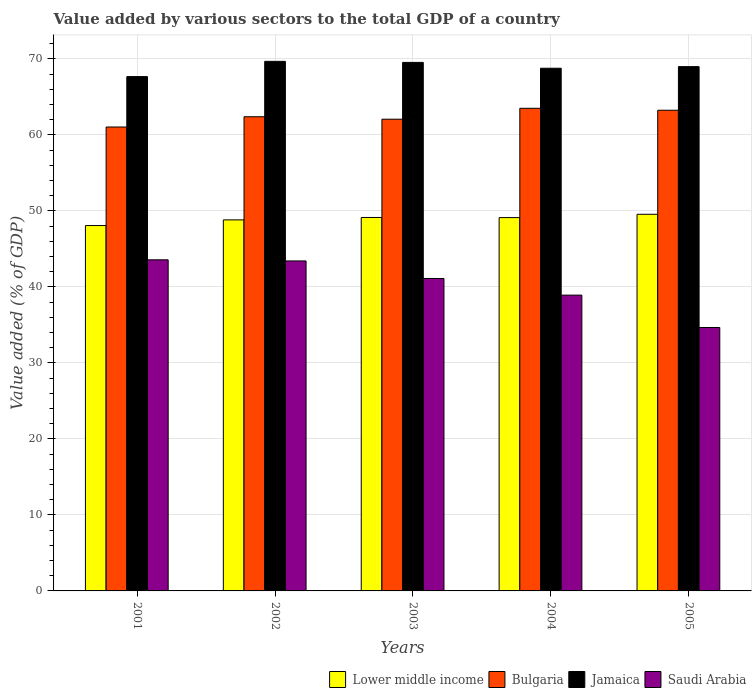How many bars are there on the 2nd tick from the right?
Keep it short and to the point. 4. In how many cases, is the number of bars for a given year not equal to the number of legend labels?
Make the answer very short. 0. What is the value added by various sectors to the total GDP in Bulgaria in 2004?
Make the answer very short. 63.51. Across all years, what is the maximum value added by various sectors to the total GDP in Saudi Arabia?
Give a very brief answer. 43.57. Across all years, what is the minimum value added by various sectors to the total GDP in Jamaica?
Your answer should be very brief. 67.68. In which year was the value added by various sectors to the total GDP in Bulgaria minimum?
Provide a succinct answer. 2001. What is the total value added by various sectors to the total GDP in Jamaica in the graph?
Offer a terse response. 344.68. What is the difference between the value added by various sectors to the total GDP in Bulgaria in 2001 and that in 2005?
Provide a succinct answer. -2.21. What is the difference between the value added by various sectors to the total GDP in Lower middle income in 2002 and the value added by various sectors to the total GDP in Saudi Arabia in 2004?
Your answer should be very brief. 9.9. What is the average value added by various sectors to the total GDP in Saudi Arabia per year?
Give a very brief answer. 40.34. In the year 2003, what is the difference between the value added by various sectors to the total GDP in Jamaica and value added by various sectors to the total GDP in Bulgaria?
Your response must be concise. 7.48. In how many years, is the value added by various sectors to the total GDP in Bulgaria greater than 62 %?
Provide a short and direct response. 4. What is the ratio of the value added by various sectors to the total GDP in Bulgaria in 2004 to that in 2005?
Offer a very short reply. 1. Is the value added by various sectors to the total GDP in Jamaica in 2003 less than that in 2004?
Keep it short and to the point. No. Is the difference between the value added by various sectors to the total GDP in Jamaica in 2001 and 2003 greater than the difference between the value added by various sectors to the total GDP in Bulgaria in 2001 and 2003?
Make the answer very short. No. What is the difference between the highest and the second highest value added by various sectors to the total GDP in Jamaica?
Offer a terse response. 0.14. What is the difference between the highest and the lowest value added by various sectors to the total GDP in Lower middle income?
Make the answer very short. 1.48. What does the 1st bar from the left in 2002 represents?
Ensure brevity in your answer.  Lower middle income. How many bars are there?
Offer a terse response. 20. What is the title of the graph?
Give a very brief answer. Value added by various sectors to the total GDP of a country. What is the label or title of the Y-axis?
Keep it short and to the point. Value added (% of GDP). What is the Value added (% of GDP) of Lower middle income in 2001?
Your answer should be very brief. 48.08. What is the Value added (% of GDP) of Bulgaria in 2001?
Give a very brief answer. 61.05. What is the Value added (% of GDP) in Jamaica in 2001?
Make the answer very short. 67.68. What is the Value added (% of GDP) of Saudi Arabia in 2001?
Offer a terse response. 43.57. What is the Value added (% of GDP) in Lower middle income in 2002?
Make the answer very short. 48.82. What is the Value added (% of GDP) of Bulgaria in 2002?
Your response must be concise. 62.4. What is the Value added (% of GDP) of Jamaica in 2002?
Your response must be concise. 69.69. What is the Value added (% of GDP) in Saudi Arabia in 2002?
Your answer should be very brief. 43.42. What is the Value added (% of GDP) of Lower middle income in 2003?
Provide a succinct answer. 49.14. What is the Value added (% of GDP) in Bulgaria in 2003?
Keep it short and to the point. 62.07. What is the Value added (% of GDP) in Jamaica in 2003?
Give a very brief answer. 69.55. What is the Value added (% of GDP) of Saudi Arabia in 2003?
Your answer should be compact. 41.11. What is the Value added (% of GDP) in Lower middle income in 2004?
Give a very brief answer. 49.12. What is the Value added (% of GDP) in Bulgaria in 2004?
Offer a very short reply. 63.51. What is the Value added (% of GDP) in Jamaica in 2004?
Provide a succinct answer. 68.78. What is the Value added (% of GDP) in Saudi Arabia in 2004?
Your response must be concise. 38.92. What is the Value added (% of GDP) in Lower middle income in 2005?
Your answer should be very brief. 49.56. What is the Value added (% of GDP) in Bulgaria in 2005?
Your answer should be compact. 63.25. What is the Value added (% of GDP) in Jamaica in 2005?
Your response must be concise. 68.99. What is the Value added (% of GDP) in Saudi Arabia in 2005?
Provide a succinct answer. 34.66. Across all years, what is the maximum Value added (% of GDP) of Lower middle income?
Your response must be concise. 49.56. Across all years, what is the maximum Value added (% of GDP) of Bulgaria?
Keep it short and to the point. 63.51. Across all years, what is the maximum Value added (% of GDP) of Jamaica?
Make the answer very short. 69.69. Across all years, what is the maximum Value added (% of GDP) of Saudi Arabia?
Keep it short and to the point. 43.57. Across all years, what is the minimum Value added (% of GDP) of Lower middle income?
Your answer should be compact. 48.08. Across all years, what is the minimum Value added (% of GDP) in Bulgaria?
Ensure brevity in your answer.  61.05. Across all years, what is the minimum Value added (% of GDP) of Jamaica?
Your answer should be very brief. 67.68. Across all years, what is the minimum Value added (% of GDP) of Saudi Arabia?
Your answer should be compact. 34.66. What is the total Value added (% of GDP) of Lower middle income in the graph?
Offer a terse response. 244.73. What is the total Value added (% of GDP) in Bulgaria in the graph?
Provide a short and direct response. 312.28. What is the total Value added (% of GDP) of Jamaica in the graph?
Offer a very short reply. 344.68. What is the total Value added (% of GDP) of Saudi Arabia in the graph?
Your response must be concise. 201.69. What is the difference between the Value added (% of GDP) in Lower middle income in 2001 and that in 2002?
Make the answer very short. -0.75. What is the difference between the Value added (% of GDP) of Bulgaria in 2001 and that in 2002?
Your response must be concise. -1.35. What is the difference between the Value added (% of GDP) of Jamaica in 2001 and that in 2002?
Your answer should be compact. -2.01. What is the difference between the Value added (% of GDP) of Saudi Arabia in 2001 and that in 2002?
Keep it short and to the point. 0.15. What is the difference between the Value added (% of GDP) of Lower middle income in 2001 and that in 2003?
Provide a short and direct response. -1.06. What is the difference between the Value added (% of GDP) of Bulgaria in 2001 and that in 2003?
Your answer should be compact. -1.03. What is the difference between the Value added (% of GDP) of Jamaica in 2001 and that in 2003?
Your answer should be very brief. -1.87. What is the difference between the Value added (% of GDP) in Saudi Arabia in 2001 and that in 2003?
Keep it short and to the point. 2.46. What is the difference between the Value added (% of GDP) of Lower middle income in 2001 and that in 2004?
Your answer should be compact. -1.05. What is the difference between the Value added (% of GDP) of Bulgaria in 2001 and that in 2004?
Provide a succinct answer. -2.46. What is the difference between the Value added (% of GDP) of Jamaica in 2001 and that in 2004?
Give a very brief answer. -1.1. What is the difference between the Value added (% of GDP) of Saudi Arabia in 2001 and that in 2004?
Provide a succinct answer. 4.65. What is the difference between the Value added (% of GDP) of Lower middle income in 2001 and that in 2005?
Make the answer very short. -1.48. What is the difference between the Value added (% of GDP) of Bulgaria in 2001 and that in 2005?
Provide a succinct answer. -2.21. What is the difference between the Value added (% of GDP) in Jamaica in 2001 and that in 2005?
Provide a succinct answer. -1.31. What is the difference between the Value added (% of GDP) in Saudi Arabia in 2001 and that in 2005?
Your answer should be compact. 8.91. What is the difference between the Value added (% of GDP) in Lower middle income in 2002 and that in 2003?
Ensure brevity in your answer.  -0.32. What is the difference between the Value added (% of GDP) of Bulgaria in 2002 and that in 2003?
Offer a terse response. 0.32. What is the difference between the Value added (% of GDP) in Jamaica in 2002 and that in 2003?
Provide a short and direct response. 0.14. What is the difference between the Value added (% of GDP) of Saudi Arabia in 2002 and that in 2003?
Provide a succinct answer. 2.31. What is the difference between the Value added (% of GDP) of Lower middle income in 2002 and that in 2004?
Provide a short and direct response. -0.3. What is the difference between the Value added (% of GDP) of Bulgaria in 2002 and that in 2004?
Keep it short and to the point. -1.11. What is the difference between the Value added (% of GDP) of Jamaica in 2002 and that in 2004?
Provide a succinct answer. 0.91. What is the difference between the Value added (% of GDP) in Saudi Arabia in 2002 and that in 2004?
Your answer should be very brief. 4.5. What is the difference between the Value added (% of GDP) in Lower middle income in 2002 and that in 2005?
Your answer should be compact. -0.74. What is the difference between the Value added (% of GDP) in Bulgaria in 2002 and that in 2005?
Provide a short and direct response. -0.86. What is the difference between the Value added (% of GDP) of Jamaica in 2002 and that in 2005?
Ensure brevity in your answer.  0.69. What is the difference between the Value added (% of GDP) in Saudi Arabia in 2002 and that in 2005?
Offer a very short reply. 8.76. What is the difference between the Value added (% of GDP) in Lower middle income in 2003 and that in 2004?
Provide a succinct answer. 0.02. What is the difference between the Value added (% of GDP) of Bulgaria in 2003 and that in 2004?
Keep it short and to the point. -1.44. What is the difference between the Value added (% of GDP) in Jamaica in 2003 and that in 2004?
Offer a very short reply. 0.77. What is the difference between the Value added (% of GDP) of Saudi Arabia in 2003 and that in 2004?
Make the answer very short. 2.19. What is the difference between the Value added (% of GDP) of Lower middle income in 2003 and that in 2005?
Offer a very short reply. -0.42. What is the difference between the Value added (% of GDP) in Bulgaria in 2003 and that in 2005?
Your response must be concise. -1.18. What is the difference between the Value added (% of GDP) in Jamaica in 2003 and that in 2005?
Your response must be concise. 0.56. What is the difference between the Value added (% of GDP) of Saudi Arabia in 2003 and that in 2005?
Offer a terse response. 6.45. What is the difference between the Value added (% of GDP) in Lower middle income in 2004 and that in 2005?
Your response must be concise. -0.44. What is the difference between the Value added (% of GDP) of Bulgaria in 2004 and that in 2005?
Your answer should be compact. 0.26. What is the difference between the Value added (% of GDP) of Jamaica in 2004 and that in 2005?
Provide a short and direct response. -0.21. What is the difference between the Value added (% of GDP) in Saudi Arabia in 2004 and that in 2005?
Provide a short and direct response. 4.26. What is the difference between the Value added (% of GDP) in Lower middle income in 2001 and the Value added (% of GDP) in Bulgaria in 2002?
Make the answer very short. -14.32. What is the difference between the Value added (% of GDP) of Lower middle income in 2001 and the Value added (% of GDP) of Jamaica in 2002?
Ensure brevity in your answer.  -21.61. What is the difference between the Value added (% of GDP) in Lower middle income in 2001 and the Value added (% of GDP) in Saudi Arabia in 2002?
Give a very brief answer. 4.66. What is the difference between the Value added (% of GDP) of Bulgaria in 2001 and the Value added (% of GDP) of Jamaica in 2002?
Ensure brevity in your answer.  -8.64. What is the difference between the Value added (% of GDP) of Bulgaria in 2001 and the Value added (% of GDP) of Saudi Arabia in 2002?
Provide a short and direct response. 17.62. What is the difference between the Value added (% of GDP) of Jamaica in 2001 and the Value added (% of GDP) of Saudi Arabia in 2002?
Provide a succinct answer. 24.26. What is the difference between the Value added (% of GDP) of Lower middle income in 2001 and the Value added (% of GDP) of Bulgaria in 2003?
Provide a short and direct response. -14. What is the difference between the Value added (% of GDP) of Lower middle income in 2001 and the Value added (% of GDP) of Jamaica in 2003?
Provide a succinct answer. -21.47. What is the difference between the Value added (% of GDP) of Lower middle income in 2001 and the Value added (% of GDP) of Saudi Arabia in 2003?
Ensure brevity in your answer.  6.97. What is the difference between the Value added (% of GDP) of Bulgaria in 2001 and the Value added (% of GDP) of Jamaica in 2003?
Offer a terse response. -8.5. What is the difference between the Value added (% of GDP) in Bulgaria in 2001 and the Value added (% of GDP) in Saudi Arabia in 2003?
Provide a succinct answer. 19.93. What is the difference between the Value added (% of GDP) of Jamaica in 2001 and the Value added (% of GDP) of Saudi Arabia in 2003?
Offer a terse response. 26.57. What is the difference between the Value added (% of GDP) in Lower middle income in 2001 and the Value added (% of GDP) in Bulgaria in 2004?
Make the answer very short. -15.43. What is the difference between the Value added (% of GDP) of Lower middle income in 2001 and the Value added (% of GDP) of Jamaica in 2004?
Your response must be concise. -20.7. What is the difference between the Value added (% of GDP) of Lower middle income in 2001 and the Value added (% of GDP) of Saudi Arabia in 2004?
Offer a very short reply. 9.15. What is the difference between the Value added (% of GDP) in Bulgaria in 2001 and the Value added (% of GDP) in Jamaica in 2004?
Provide a short and direct response. -7.73. What is the difference between the Value added (% of GDP) in Bulgaria in 2001 and the Value added (% of GDP) in Saudi Arabia in 2004?
Ensure brevity in your answer.  22.12. What is the difference between the Value added (% of GDP) of Jamaica in 2001 and the Value added (% of GDP) of Saudi Arabia in 2004?
Provide a succinct answer. 28.75. What is the difference between the Value added (% of GDP) of Lower middle income in 2001 and the Value added (% of GDP) of Bulgaria in 2005?
Offer a very short reply. -15.17. What is the difference between the Value added (% of GDP) of Lower middle income in 2001 and the Value added (% of GDP) of Jamaica in 2005?
Ensure brevity in your answer.  -20.91. What is the difference between the Value added (% of GDP) of Lower middle income in 2001 and the Value added (% of GDP) of Saudi Arabia in 2005?
Make the answer very short. 13.41. What is the difference between the Value added (% of GDP) in Bulgaria in 2001 and the Value added (% of GDP) in Jamaica in 2005?
Your response must be concise. -7.94. What is the difference between the Value added (% of GDP) of Bulgaria in 2001 and the Value added (% of GDP) of Saudi Arabia in 2005?
Your answer should be compact. 26.38. What is the difference between the Value added (% of GDP) of Jamaica in 2001 and the Value added (% of GDP) of Saudi Arabia in 2005?
Give a very brief answer. 33.01. What is the difference between the Value added (% of GDP) in Lower middle income in 2002 and the Value added (% of GDP) in Bulgaria in 2003?
Your answer should be very brief. -13.25. What is the difference between the Value added (% of GDP) of Lower middle income in 2002 and the Value added (% of GDP) of Jamaica in 2003?
Offer a very short reply. -20.72. What is the difference between the Value added (% of GDP) in Lower middle income in 2002 and the Value added (% of GDP) in Saudi Arabia in 2003?
Provide a succinct answer. 7.71. What is the difference between the Value added (% of GDP) of Bulgaria in 2002 and the Value added (% of GDP) of Jamaica in 2003?
Give a very brief answer. -7.15. What is the difference between the Value added (% of GDP) of Bulgaria in 2002 and the Value added (% of GDP) of Saudi Arabia in 2003?
Ensure brevity in your answer.  21.28. What is the difference between the Value added (% of GDP) in Jamaica in 2002 and the Value added (% of GDP) in Saudi Arabia in 2003?
Provide a short and direct response. 28.57. What is the difference between the Value added (% of GDP) of Lower middle income in 2002 and the Value added (% of GDP) of Bulgaria in 2004?
Offer a very short reply. -14.69. What is the difference between the Value added (% of GDP) in Lower middle income in 2002 and the Value added (% of GDP) in Jamaica in 2004?
Keep it short and to the point. -19.95. What is the difference between the Value added (% of GDP) of Lower middle income in 2002 and the Value added (% of GDP) of Saudi Arabia in 2004?
Provide a short and direct response. 9.9. What is the difference between the Value added (% of GDP) in Bulgaria in 2002 and the Value added (% of GDP) in Jamaica in 2004?
Your answer should be compact. -6.38. What is the difference between the Value added (% of GDP) of Bulgaria in 2002 and the Value added (% of GDP) of Saudi Arabia in 2004?
Provide a short and direct response. 23.47. What is the difference between the Value added (% of GDP) in Jamaica in 2002 and the Value added (% of GDP) in Saudi Arabia in 2004?
Give a very brief answer. 30.76. What is the difference between the Value added (% of GDP) of Lower middle income in 2002 and the Value added (% of GDP) of Bulgaria in 2005?
Your answer should be very brief. -14.43. What is the difference between the Value added (% of GDP) in Lower middle income in 2002 and the Value added (% of GDP) in Jamaica in 2005?
Your response must be concise. -20.17. What is the difference between the Value added (% of GDP) of Lower middle income in 2002 and the Value added (% of GDP) of Saudi Arabia in 2005?
Ensure brevity in your answer.  14.16. What is the difference between the Value added (% of GDP) in Bulgaria in 2002 and the Value added (% of GDP) in Jamaica in 2005?
Offer a terse response. -6.59. What is the difference between the Value added (% of GDP) in Bulgaria in 2002 and the Value added (% of GDP) in Saudi Arabia in 2005?
Your response must be concise. 27.73. What is the difference between the Value added (% of GDP) in Jamaica in 2002 and the Value added (% of GDP) in Saudi Arabia in 2005?
Your answer should be very brief. 35.02. What is the difference between the Value added (% of GDP) of Lower middle income in 2003 and the Value added (% of GDP) of Bulgaria in 2004?
Provide a short and direct response. -14.37. What is the difference between the Value added (% of GDP) in Lower middle income in 2003 and the Value added (% of GDP) in Jamaica in 2004?
Offer a very short reply. -19.64. What is the difference between the Value added (% of GDP) of Lower middle income in 2003 and the Value added (% of GDP) of Saudi Arabia in 2004?
Provide a short and direct response. 10.22. What is the difference between the Value added (% of GDP) of Bulgaria in 2003 and the Value added (% of GDP) of Jamaica in 2004?
Your answer should be very brief. -6.71. What is the difference between the Value added (% of GDP) of Bulgaria in 2003 and the Value added (% of GDP) of Saudi Arabia in 2004?
Provide a succinct answer. 23.15. What is the difference between the Value added (% of GDP) in Jamaica in 2003 and the Value added (% of GDP) in Saudi Arabia in 2004?
Offer a very short reply. 30.62. What is the difference between the Value added (% of GDP) of Lower middle income in 2003 and the Value added (% of GDP) of Bulgaria in 2005?
Keep it short and to the point. -14.11. What is the difference between the Value added (% of GDP) in Lower middle income in 2003 and the Value added (% of GDP) in Jamaica in 2005?
Your answer should be compact. -19.85. What is the difference between the Value added (% of GDP) in Lower middle income in 2003 and the Value added (% of GDP) in Saudi Arabia in 2005?
Offer a very short reply. 14.48. What is the difference between the Value added (% of GDP) in Bulgaria in 2003 and the Value added (% of GDP) in Jamaica in 2005?
Provide a short and direct response. -6.92. What is the difference between the Value added (% of GDP) in Bulgaria in 2003 and the Value added (% of GDP) in Saudi Arabia in 2005?
Provide a succinct answer. 27.41. What is the difference between the Value added (% of GDP) in Jamaica in 2003 and the Value added (% of GDP) in Saudi Arabia in 2005?
Give a very brief answer. 34.88. What is the difference between the Value added (% of GDP) of Lower middle income in 2004 and the Value added (% of GDP) of Bulgaria in 2005?
Offer a very short reply. -14.13. What is the difference between the Value added (% of GDP) in Lower middle income in 2004 and the Value added (% of GDP) in Jamaica in 2005?
Offer a very short reply. -19.87. What is the difference between the Value added (% of GDP) in Lower middle income in 2004 and the Value added (% of GDP) in Saudi Arabia in 2005?
Your answer should be compact. 14.46. What is the difference between the Value added (% of GDP) in Bulgaria in 2004 and the Value added (% of GDP) in Jamaica in 2005?
Provide a short and direct response. -5.48. What is the difference between the Value added (% of GDP) of Bulgaria in 2004 and the Value added (% of GDP) of Saudi Arabia in 2005?
Keep it short and to the point. 28.84. What is the difference between the Value added (% of GDP) in Jamaica in 2004 and the Value added (% of GDP) in Saudi Arabia in 2005?
Keep it short and to the point. 34.11. What is the average Value added (% of GDP) in Lower middle income per year?
Offer a very short reply. 48.95. What is the average Value added (% of GDP) of Bulgaria per year?
Offer a very short reply. 62.46. What is the average Value added (% of GDP) of Jamaica per year?
Ensure brevity in your answer.  68.94. What is the average Value added (% of GDP) in Saudi Arabia per year?
Your answer should be compact. 40.34. In the year 2001, what is the difference between the Value added (% of GDP) in Lower middle income and Value added (% of GDP) in Bulgaria?
Provide a short and direct response. -12.97. In the year 2001, what is the difference between the Value added (% of GDP) in Lower middle income and Value added (% of GDP) in Jamaica?
Make the answer very short. -19.6. In the year 2001, what is the difference between the Value added (% of GDP) in Lower middle income and Value added (% of GDP) in Saudi Arabia?
Offer a terse response. 4.51. In the year 2001, what is the difference between the Value added (% of GDP) of Bulgaria and Value added (% of GDP) of Jamaica?
Make the answer very short. -6.63. In the year 2001, what is the difference between the Value added (% of GDP) of Bulgaria and Value added (% of GDP) of Saudi Arabia?
Make the answer very short. 17.48. In the year 2001, what is the difference between the Value added (% of GDP) in Jamaica and Value added (% of GDP) in Saudi Arabia?
Make the answer very short. 24.11. In the year 2002, what is the difference between the Value added (% of GDP) in Lower middle income and Value added (% of GDP) in Bulgaria?
Give a very brief answer. -13.57. In the year 2002, what is the difference between the Value added (% of GDP) of Lower middle income and Value added (% of GDP) of Jamaica?
Your answer should be compact. -20.86. In the year 2002, what is the difference between the Value added (% of GDP) in Lower middle income and Value added (% of GDP) in Saudi Arabia?
Your answer should be compact. 5.4. In the year 2002, what is the difference between the Value added (% of GDP) in Bulgaria and Value added (% of GDP) in Jamaica?
Keep it short and to the point. -7.29. In the year 2002, what is the difference between the Value added (% of GDP) of Bulgaria and Value added (% of GDP) of Saudi Arabia?
Make the answer very short. 18.97. In the year 2002, what is the difference between the Value added (% of GDP) of Jamaica and Value added (% of GDP) of Saudi Arabia?
Provide a short and direct response. 26.26. In the year 2003, what is the difference between the Value added (% of GDP) of Lower middle income and Value added (% of GDP) of Bulgaria?
Your answer should be compact. -12.93. In the year 2003, what is the difference between the Value added (% of GDP) in Lower middle income and Value added (% of GDP) in Jamaica?
Offer a terse response. -20.41. In the year 2003, what is the difference between the Value added (% of GDP) in Lower middle income and Value added (% of GDP) in Saudi Arabia?
Keep it short and to the point. 8.03. In the year 2003, what is the difference between the Value added (% of GDP) of Bulgaria and Value added (% of GDP) of Jamaica?
Make the answer very short. -7.47. In the year 2003, what is the difference between the Value added (% of GDP) in Bulgaria and Value added (% of GDP) in Saudi Arabia?
Your response must be concise. 20.96. In the year 2003, what is the difference between the Value added (% of GDP) in Jamaica and Value added (% of GDP) in Saudi Arabia?
Offer a terse response. 28.44. In the year 2004, what is the difference between the Value added (% of GDP) of Lower middle income and Value added (% of GDP) of Bulgaria?
Provide a succinct answer. -14.39. In the year 2004, what is the difference between the Value added (% of GDP) in Lower middle income and Value added (% of GDP) in Jamaica?
Give a very brief answer. -19.65. In the year 2004, what is the difference between the Value added (% of GDP) in Lower middle income and Value added (% of GDP) in Saudi Arabia?
Your response must be concise. 10.2. In the year 2004, what is the difference between the Value added (% of GDP) of Bulgaria and Value added (% of GDP) of Jamaica?
Your answer should be compact. -5.27. In the year 2004, what is the difference between the Value added (% of GDP) of Bulgaria and Value added (% of GDP) of Saudi Arabia?
Give a very brief answer. 24.59. In the year 2004, what is the difference between the Value added (% of GDP) of Jamaica and Value added (% of GDP) of Saudi Arabia?
Provide a short and direct response. 29.85. In the year 2005, what is the difference between the Value added (% of GDP) in Lower middle income and Value added (% of GDP) in Bulgaria?
Offer a terse response. -13.69. In the year 2005, what is the difference between the Value added (% of GDP) of Lower middle income and Value added (% of GDP) of Jamaica?
Ensure brevity in your answer.  -19.43. In the year 2005, what is the difference between the Value added (% of GDP) in Lower middle income and Value added (% of GDP) in Saudi Arabia?
Make the answer very short. 14.9. In the year 2005, what is the difference between the Value added (% of GDP) of Bulgaria and Value added (% of GDP) of Jamaica?
Offer a terse response. -5.74. In the year 2005, what is the difference between the Value added (% of GDP) of Bulgaria and Value added (% of GDP) of Saudi Arabia?
Provide a succinct answer. 28.59. In the year 2005, what is the difference between the Value added (% of GDP) of Jamaica and Value added (% of GDP) of Saudi Arabia?
Keep it short and to the point. 34.33. What is the ratio of the Value added (% of GDP) of Lower middle income in 2001 to that in 2002?
Keep it short and to the point. 0.98. What is the ratio of the Value added (% of GDP) of Bulgaria in 2001 to that in 2002?
Offer a very short reply. 0.98. What is the ratio of the Value added (% of GDP) of Jamaica in 2001 to that in 2002?
Your answer should be very brief. 0.97. What is the ratio of the Value added (% of GDP) of Lower middle income in 2001 to that in 2003?
Make the answer very short. 0.98. What is the ratio of the Value added (% of GDP) in Bulgaria in 2001 to that in 2003?
Keep it short and to the point. 0.98. What is the ratio of the Value added (% of GDP) of Jamaica in 2001 to that in 2003?
Your answer should be compact. 0.97. What is the ratio of the Value added (% of GDP) in Saudi Arabia in 2001 to that in 2003?
Keep it short and to the point. 1.06. What is the ratio of the Value added (% of GDP) of Lower middle income in 2001 to that in 2004?
Your answer should be very brief. 0.98. What is the ratio of the Value added (% of GDP) of Bulgaria in 2001 to that in 2004?
Your answer should be very brief. 0.96. What is the ratio of the Value added (% of GDP) of Jamaica in 2001 to that in 2004?
Offer a terse response. 0.98. What is the ratio of the Value added (% of GDP) of Saudi Arabia in 2001 to that in 2004?
Provide a succinct answer. 1.12. What is the ratio of the Value added (% of GDP) of Bulgaria in 2001 to that in 2005?
Your response must be concise. 0.97. What is the ratio of the Value added (% of GDP) in Jamaica in 2001 to that in 2005?
Your answer should be compact. 0.98. What is the ratio of the Value added (% of GDP) in Saudi Arabia in 2001 to that in 2005?
Make the answer very short. 1.26. What is the ratio of the Value added (% of GDP) of Lower middle income in 2002 to that in 2003?
Provide a succinct answer. 0.99. What is the ratio of the Value added (% of GDP) in Saudi Arabia in 2002 to that in 2003?
Offer a very short reply. 1.06. What is the ratio of the Value added (% of GDP) of Lower middle income in 2002 to that in 2004?
Provide a short and direct response. 0.99. What is the ratio of the Value added (% of GDP) in Bulgaria in 2002 to that in 2004?
Your response must be concise. 0.98. What is the ratio of the Value added (% of GDP) of Jamaica in 2002 to that in 2004?
Ensure brevity in your answer.  1.01. What is the ratio of the Value added (% of GDP) of Saudi Arabia in 2002 to that in 2004?
Provide a succinct answer. 1.12. What is the ratio of the Value added (% of GDP) in Lower middle income in 2002 to that in 2005?
Give a very brief answer. 0.99. What is the ratio of the Value added (% of GDP) of Bulgaria in 2002 to that in 2005?
Your answer should be very brief. 0.99. What is the ratio of the Value added (% of GDP) in Saudi Arabia in 2002 to that in 2005?
Make the answer very short. 1.25. What is the ratio of the Value added (% of GDP) in Bulgaria in 2003 to that in 2004?
Provide a short and direct response. 0.98. What is the ratio of the Value added (% of GDP) of Jamaica in 2003 to that in 2004?
Provide a short and direct response. 1.01. What is the ratio of the Value added (% of GDP) of Saudi Arabia in 2003 to that in 2004?
Offer a very short reply. 1.06. What is the ratio of the Value added (% of GDP) in Lower middle income in 2003 to that in 2005?
Provide a succinct answer. 0.99. What is the ratio of the Value added (% of GDP) of Bulgaria in 2003 to that in 2005?
Provide a succinct answer. 0.98. What is the ratio of the Value added (% of GDP) in Jamaica in 2003 to that in 2005?
Provide a succinct answer. 1.01. What is the ratio of the Value added (% of GDP) of Saudi Arabia in 2003 to that in 2005?
Your answer should be very brief. 1.19. What is the ratio of the Value added (% of GDP) in Bulgaria in 2004 to that in 2005?
Your answer should be very brief. 1. What is the ratio of the Value added (% of GDP) of Saudi Arabia in 2004 to that in 2005?
Make the answer very short. 1.12. What is the difference between the highest and the second highest Value added (% of GDP) of Lower middle income?
Your answer should be very brief. 0.42. What is the difference between the highest and the second highest Value added (% of GDP) of Bulgaria?
Provide a succinct answer. 0.26. What is the difference between the highest and the second highest Value added (% of GDP) of Jamaica?
Keep it short and to the point. 0.14. What is the difference between the highest and the second highest Value added (% of GDP) in Saudi Arabia?
Make the answer very short. 0.15. What is the difference between the highest and the lowest Value added (% of GDP) of Lower middle income?
Your response must be concise. 1.48. What is the difference between the highest and the lowest Value added (% of GDP) in Bulgaria?
Offer a very short reply. 2.46. What is the difference between the highest and the lowest Value added (% of GDP) of Jamaica?
Give a very brief answer. 2.01. What is the difference between the highest and the lowest Value added (% of GDP) in Saudi Arabia?
Your response must be concise. 8.91. 